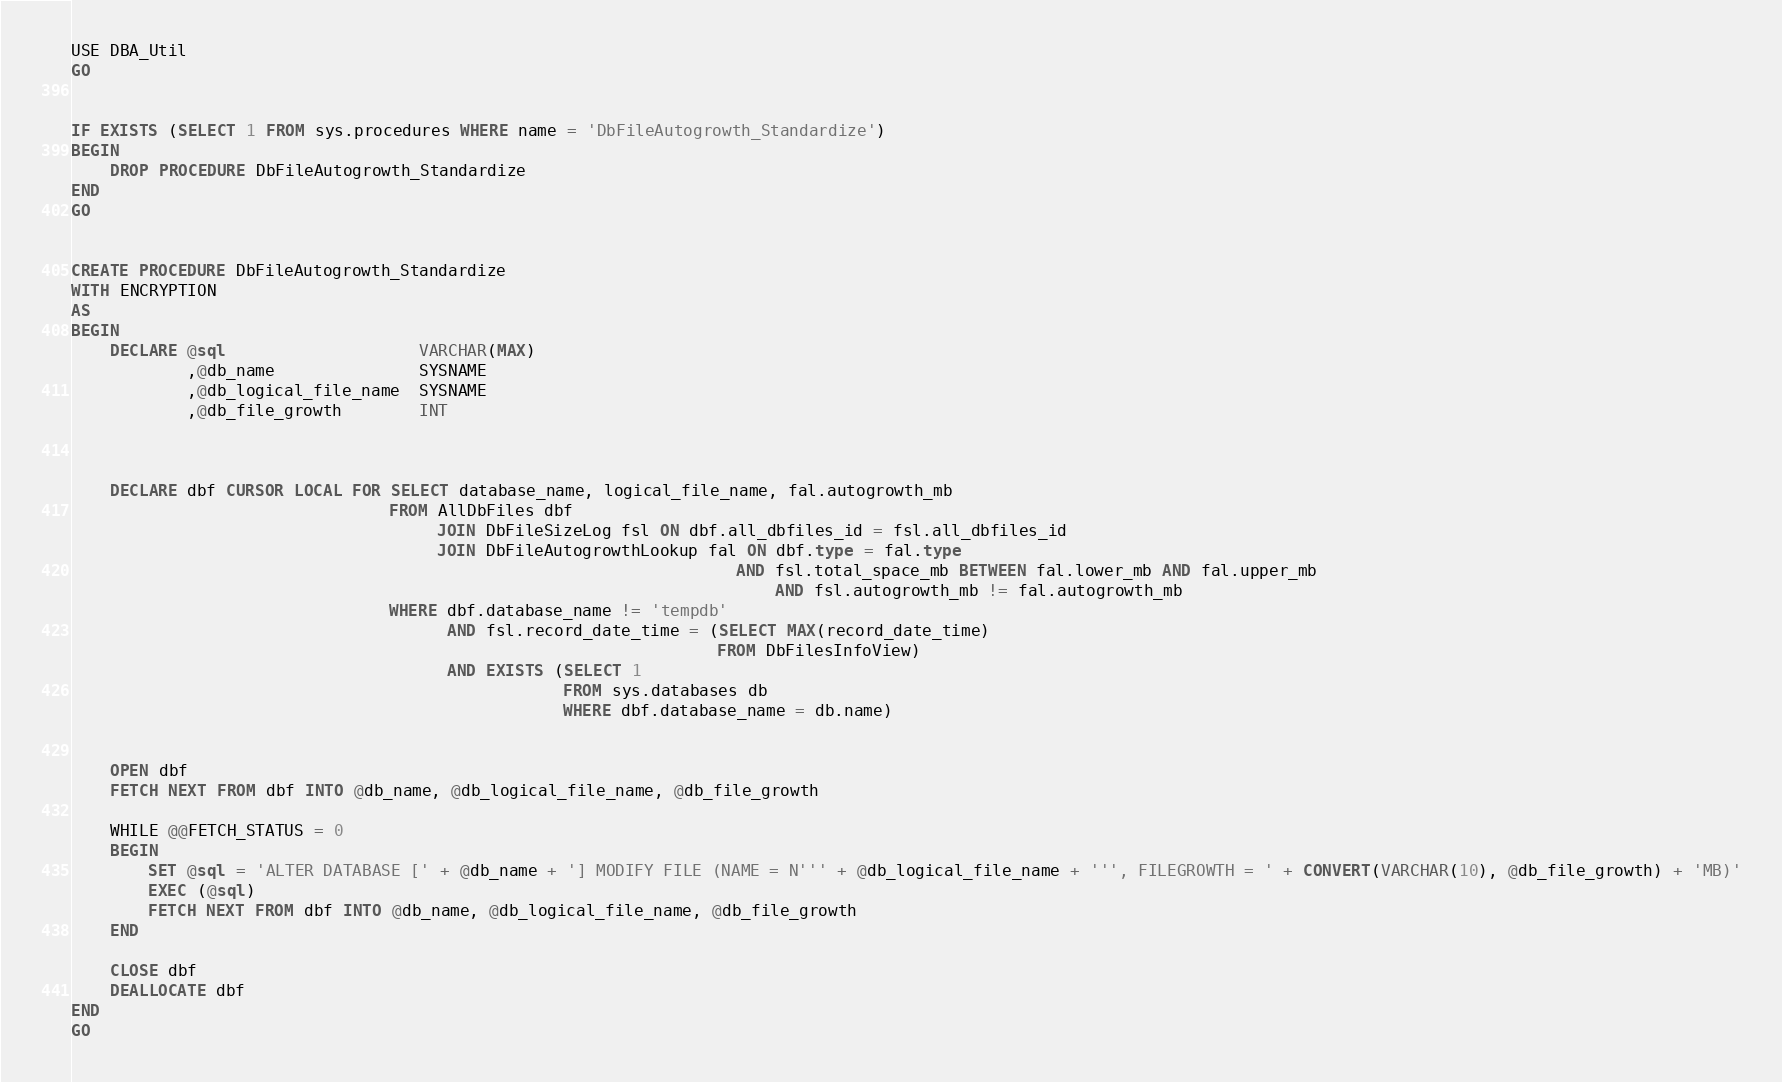<code> <loc_0><loc_0><loc_500><loc_500><_SQL_>USE DBA_Util
GO


IF EXISTS (SELECT 1 FROM sys.procedures WHERE name = 'DbFileAutogrowth_Standardize')
BEGIN
    DROP PROCEDURE DbFileAutogrowth_Standardize 
END
GO


CREATE PROCEDURE DbFileAutogrowth_Standardize
WITH ENCRYPTION
AS
BEGIN
    DECLARE @sql                    VARCHAR(MAX)
            ,@db_name               SYSNAME
            ,@db_logical_file_name  SYSNAME
            ,@db_file_growth        INT



    DECLARE dbf CURSOR LOCAL FOR SELECT database_name, logical_file_name, fal.autogrowth_mb
                                 FROM AllDbFiles dbf
                                      JOIN DbFileSizeLog fsl ON dbf.all_dbfiles_id = fsl.all_dbfiles_id
                                      JOIN DbFileAutogrowthLookup fal ON dbf.type = fal.type
	                                                                 AND fsl.total_space_mb BETWEEN fal.lower_mb AND fal.upper_mb
                                                                         AND fsl.autogrowth_mb != fal.autogrowth_mb
                                 WHERE dbf.database_name != 'tempdb'
                                       AND fsl.record_date_time = (SELECT MAX(record_date_time)
                                                                   FROM DbFilesInfoView)
                                       AND EXISTS (SELECT 1
                                                   FROM sys.databases db
                                                   WHERE dbf.database_name = db.name)


    OPEN dbf
    FETCH NEXT FROM dbf INTO @db_name, @db_logical_file_name, @db_file_growth

    WHILE @@FETCH_STATUS = 0
    BEGIN
        SET @sql = 'ALTER DATABASE [' + @db_name + '] MODIFY FILE (NAME = N''' + @db_logical_file_name + ''', FILEGROWTH = ' + CONVERT(VARCHAR(10), @db_file_growth) + 'MB)'
        EXEC (@sql)
        FETCH NEXT FROM dbf INTO @db_name, @db_logical_file_name, @db_file_growth
    END

    CLOSE dbf
    DEALLOCATE dbf
END
GO
</code> 